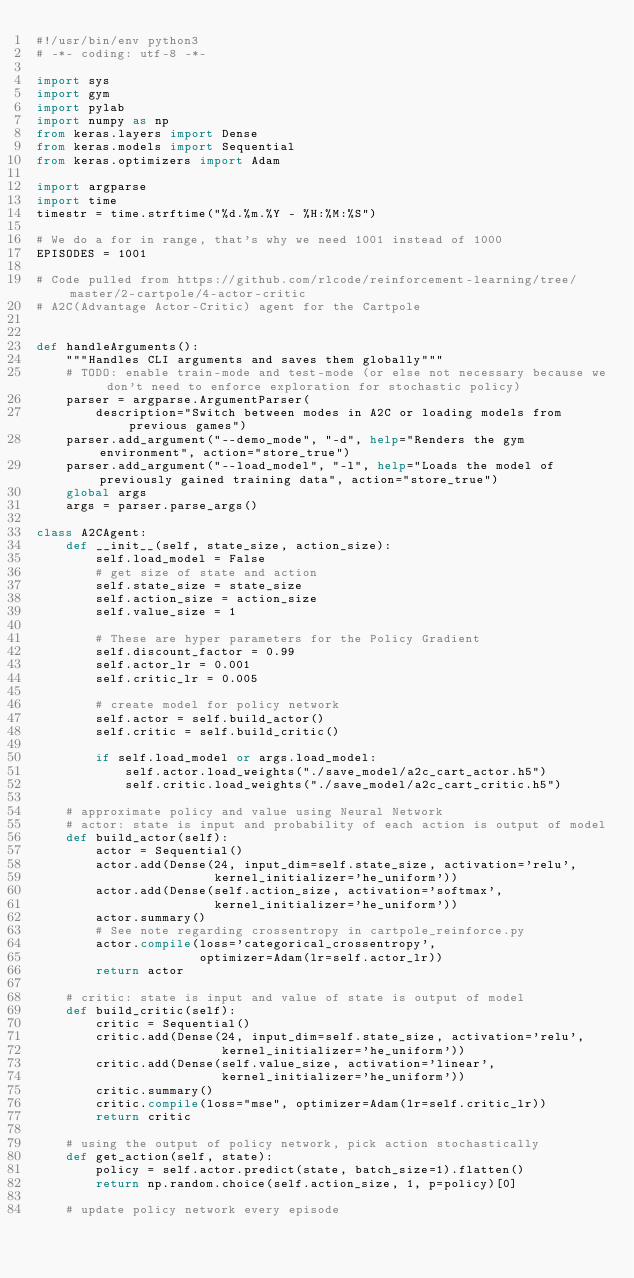<code> <loc_0><loc_0><loc_500><loc_500><_Python_>#!/usr/bin/env python3
# -*- coding: utf-8 -*-

import sys
import gym
import pylab
import numpy as np
from keras.layers import Dense
from keras.models import Sequential
from keras.optimizers import Adam

import argparse
import time
timestr = time.strftime("%d.%m.%Y - %H:%M:%S")

# We do a for in range, that's why we need 1001 instead of 1000
EPISODES = 1001

# Code pulled from https://github.com/rlcode/reinforcement-learning/tree/master/2-cartpole/4-actor-critic
# A2C(Advantage Actor-Critic) agent for the Cartpole


def handleArguments():
    """Handles CLI arguments and saves them globally"""
    # TODO: enable train-mode and test-mode (or else not necessary because we don't need to enforce exploration for stochastic policy)
    parser = argparse.ArgumentParser(
        description="Switch between modes in A2C or loading models from previous games")
    parser.add_argument("--demo_mode", "-d", help="Renders the gym environment", action="store_true")
    parser.add_argument("--load_model", "-l", help="Loads the model of previously gained training data", action="store_true")
    global args
    args = parser.parse_args()

class A2CAgent:
    def __init__(self, state_size, action_size):
        self.load_model = False
        # get size of state and action
        self.state_size = state_size
        self.action_size = action_size
        self.value_size = 1

        # These are hyper parameters for the Policy Gradient
        self.discount_factor = 0.99
        self.actor_lr = 0.001
        self.critic_lr = 0.005

        # create model for policy network
        self.actor = self.build_actor()
        self.critic = self.build_critic()

        if self.load_model or args.load_model:
            self.actor.load_weights("./save_model/a2c_cart_actor.h5")
            self.critic.load_weights("./save_model/a2c_cart_critic.h5")

    # approximate policy and value using Neural Network
    # actor: state is input and probability of each action is output of model
    def build_actor(self):
        actor = Sequential()
        actor.add(Dense(24, input_dim=self.state_size, activation='relu',
                        kernel_initializer='he_uniform'))
        actor.add(Dense(self.action_size, activation='softmax',
                        kernel_initializer='he_uniform'))
        actor.summary()
        # See note regarding crossentropy in cartpole_reinforce.py
        actor.compile(loss='categorical_crossentropy',
                      optimizer=Adam(lr=self.actor_lr))
        return actor

    # critic: state is input and value of state is output of model
    def build_critic(self):
        critic = Sequential()
        critic.add(Dense(24, input_dim=self.state_size, activation='relu',
                         kernel_initializer='he_uniform'))
        critic.add(Dense(self.value_size, activation='linear',
                         kernel_initializer='he_uniform'))
        critic.summary()
        critic.compile(loss="mse", optimizer=Adam(lr=self.critic_lr))
        return critic

    # using the output of policy network, pick action stochastically
    def get_action(self, state):
        policy = self.actor.predict(state, batch_size=1).flatten()
        return np.random.choice(self.action_size, 1, p=policy)[0]

    # update policy network every episode</code> 